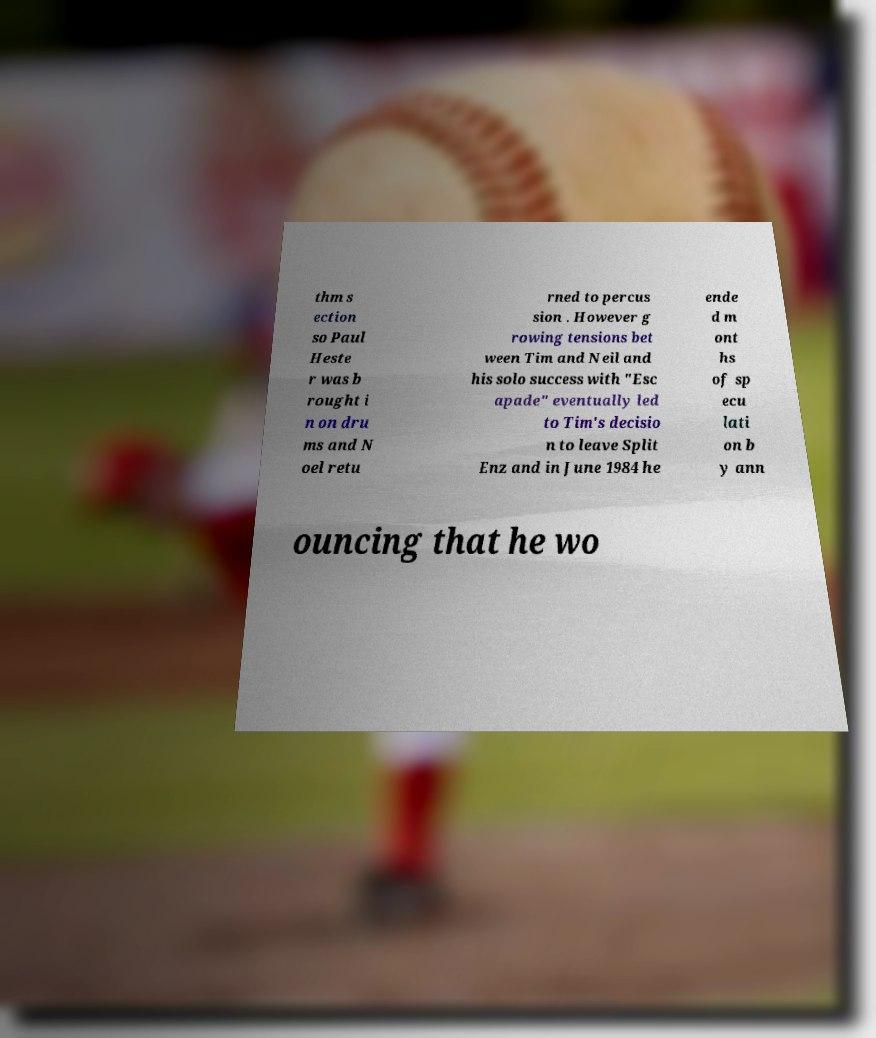What messages or text are displayed in this image? I need them in a readable, typed format. thm s ection so Paul Heste r was b rought i n on dru ms and N oel retu rned to percus sion . However g rowing tensions bet ween Tim and Neil and his solo success with "Esc apade" eventually led to Tim's decisio n to leave Split Enz and in June 1984 he ende d m ont hs of sp ecu lati on b y ann ouncing that he wo 